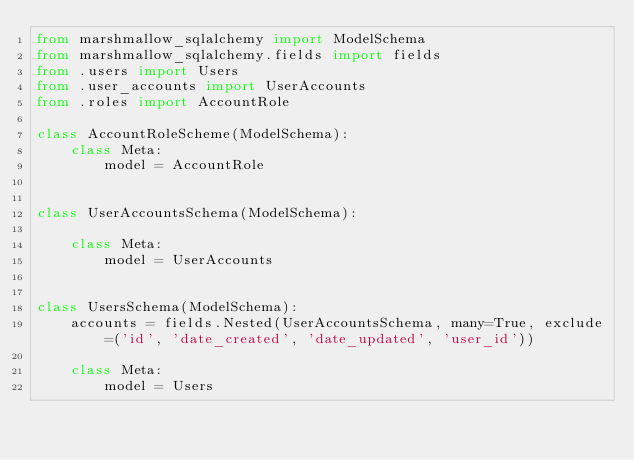Convert code to text. <code><loc_0><loc_0><loc_500><loc_500><_Python_>from marshmallow_sqlalchemy import ModelSchema
from marshmallow_sqlalchemy.fields import fields
from .users import Users
from .user_accounts import UserAccounts
from .roles import AccountRole

class AccountRoleScheme(ModelSchema):
    class Meta:
        model = AccountRole


class UserAccountsSchema(ModelSchema):

    class Meta:
        model = UserAccounts


class UsersSchema(ModelSchema):
    accounts = fields.Nested(UserAccountsSchema, many=True, exclude=('id', 'date_created', 'date_updated', 'user_id'))

    class Meta:
        model = Users
</code> 